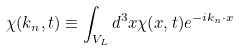Convert formula to latex. <formula><loc_0><loc_0><loc_500><loc_500>\chi ( { k } _ { n } , t ) \equiv \int _ { V _ { L } } d ^ { 3 } { x } \chi ( { x } , t ) e ^ { - i { k } _ { n } \cdot { x } }</formula> 